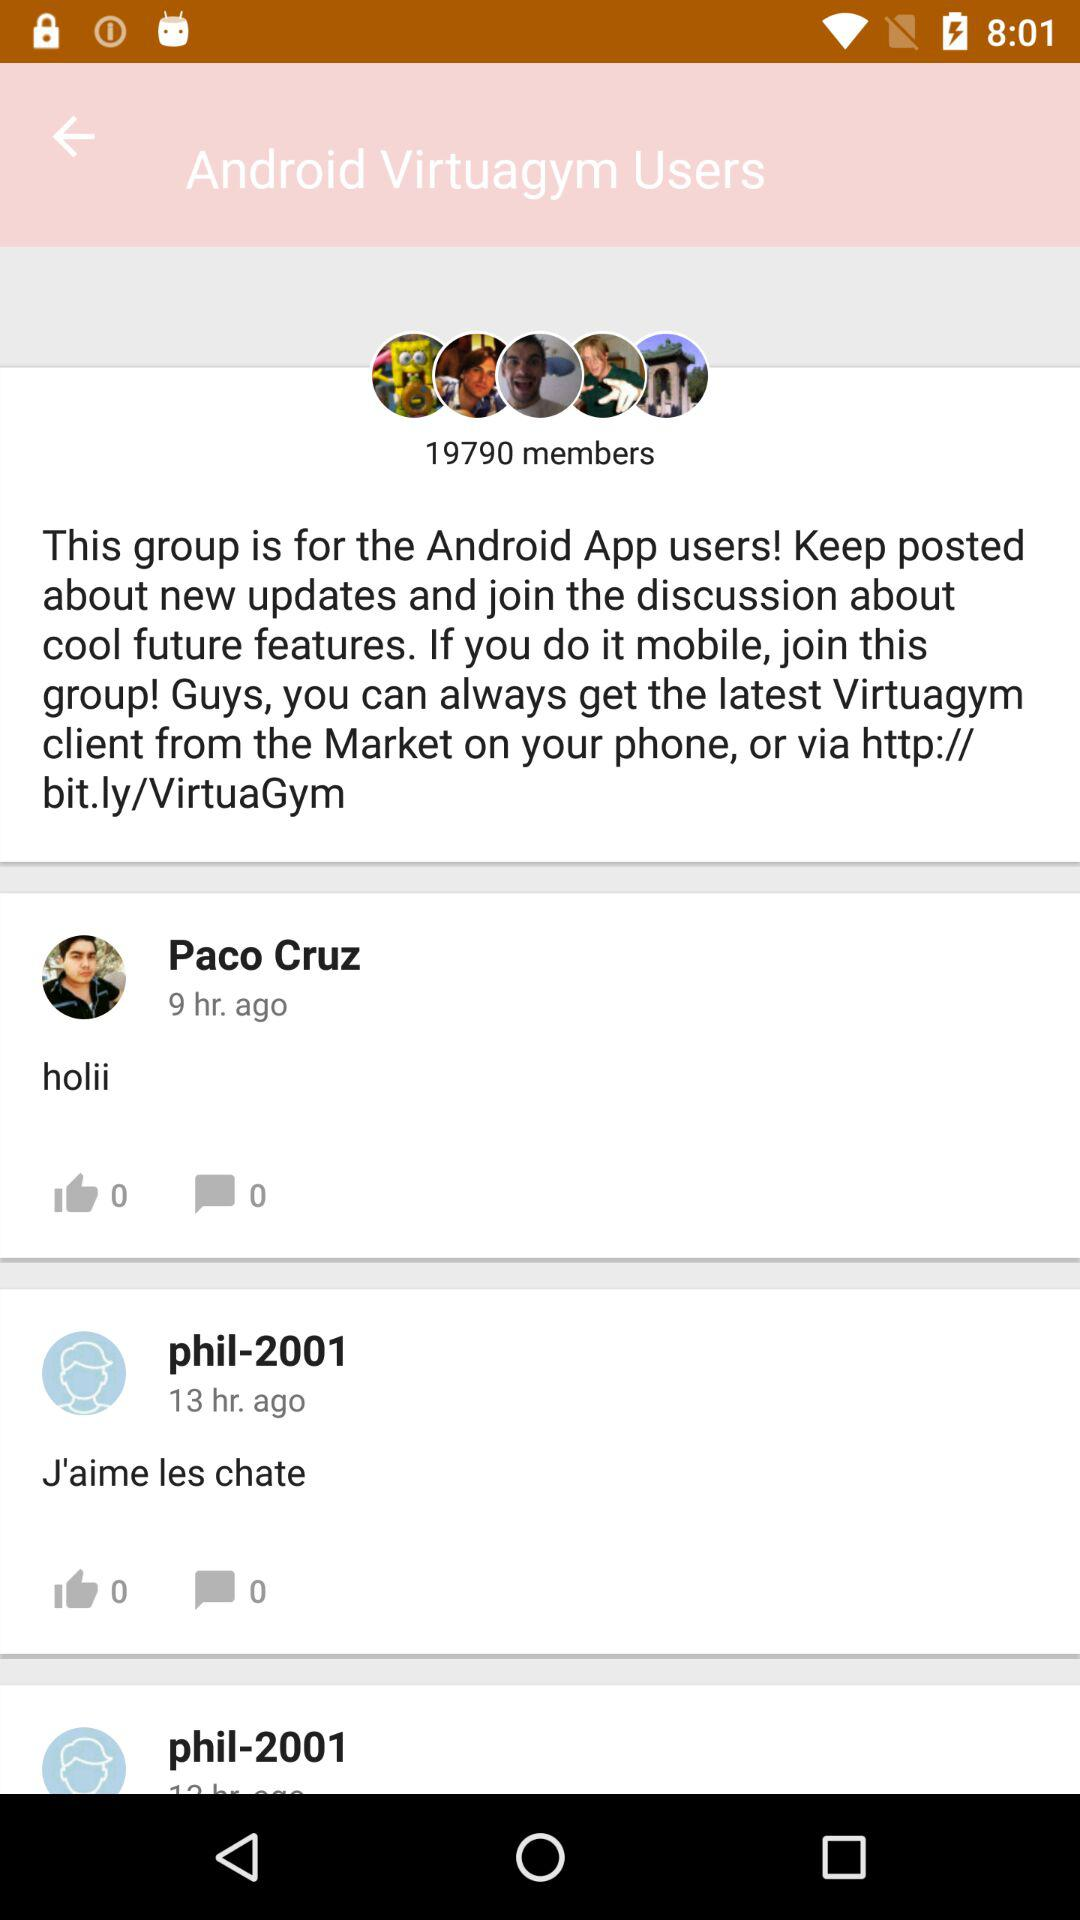How many comments are there on the post by "phil-2001"? There are 0 comments on the post by "phil-2001". 